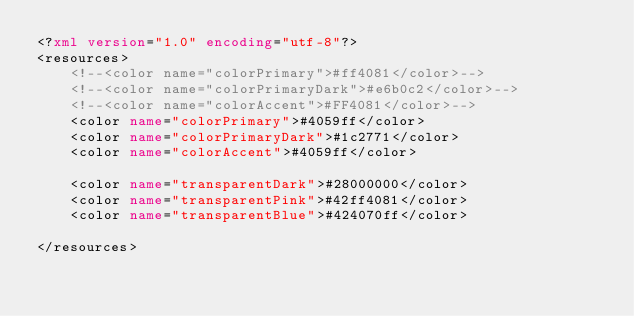Convert code to text. <code><loc_0><loc_0><loc_500><loc_500><_XML_><?xml version="1.0" encoding="utf-8"?>
<resources>
    <!--<color name="colorPrimary">#ff4081</color>-->
    <!--<color name="colorPrimaryDark">#e6b0c2</color>-->
    <!--<color name="colorAccent">#FF4081</color>-->
    <color name="colorPrimary">#4059ff</color>
    <color name="colorPrimaryDark">#1c2771</color>
    <color name="colorAccent">#4059ff</color>

    <color name="transparentDark">#28000000</color>
    <color name="transparentPink">#42ff4081</color>
    <color name="transparentBlue">#424070ff</color>

</resources>
</code> 